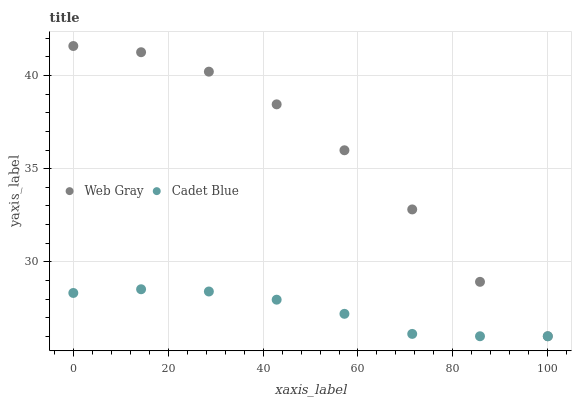Does Cadet Blue have the minimum area under the curve?
Answer yes or no. Yes. Does Web Gray have the maximum area under the curve?
Answer yes or no. Yes. Does Web Gray have the minimum area under the curve?
Answer yes or no. No. Is Cadet Blue the smoothest?
Answer yes or no. Yes. Is Web Gray the roughest?
Answer yes or no. Yes. Is Web Gray the smoothest?
Answer yes or no. No. Does Cadet Blue have the lowest value?
Answer yes or no. Yes. Does Web Gray have the highest value?
Answer yes or no. Yes. Does Web Gray intersect Cadet Blue?
Answer yes or no. Yes. Is Web Gray less than Cadet Blue?
Answer yes or no. No. Is Web Gray greater than Cadet Blue?
Answer yes or no. No. 